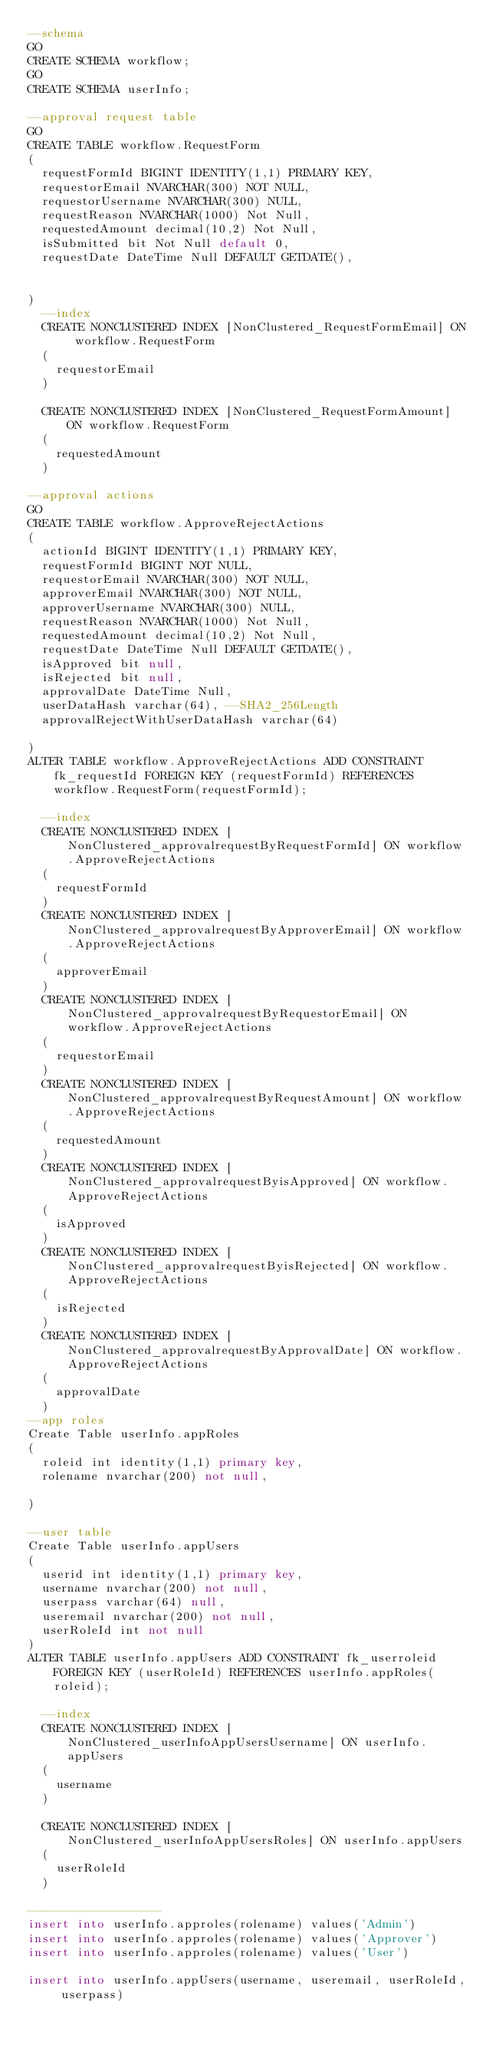<code> <loc_0><loc_0><loc_500><loc_500><_SQL_>--schema
GO 
CREATE SCHEMA workflow;
GO 
CREATE SCHEMA userInfo;

--approval request table
GO
CREATE TABLE workflow.RequestForm
(
	requestFormId BIGINT IDENTITY(1,1) PRIMARY KEY,
	requestorEmail NVARCHAR(300) NOT NULL,
	requestorUsername NVARCHAR(300) NULL,
	requestReason NVARCHAR(1000) Not Null,
	requestedAmount decimal(10,2) Not Null,
	isSubmitted bit Not Null default 0,
	requestDate DateTime Null DEFAULT GETDATE(),
	
	
)
	--index
	CREATE NONCLUSTERED INDEX [NonClustered_RequestFormEmail] ON workflow.RequestForm
	(
		requestorEmail
	)

	CREATE NONCLUSTERED INDEX [NonClustered_RequestFormAmount] ON workflow.RequestForm
	(
		requestedAmount
	)

--approval actions
GO
CREATE TABLE workflow.ApproveRejectActions
(
	actionId BIGINT IDENTITY(1,1) PRIMARY KEY,
	requestFormId BIGINT NOT NULL,
	requestorEmail NVARCHAR(300) NOT NULL,
	approverEmail NVARCHAR(300) NOT NULL,
	approverUsername NVARCHAR(300) NULL,
	requestReason NVARCHAR(1000) Not Null,
	requestedAmount decimal(10,2) Not Null,
	requestDate DateTime Null DEFAULT GETDATE(),
	isApproved bit null,
	isRejected bit null,
	approvalDate DateTime Null,
	userDataHash varchar(64), --SHA2_256Length
	approvalRejectWithUserDataHash varchar(64)
	
)
ALTER TABLE workflow.ApproveRejectActions ADD CONSTRAINT fk_requestId FOREIGN KEY (requestFormId) REFERENCES workflow.RequestForm(requestFormId);

	--index
	CREATE NONCLUSTERED INDEX [NonClustered_approvalrequestByRequestFormId] ON workflow.ApproveRejectActions
	(
		requestFormId
	)
	CREATE NONCLUSTERED INDEX [NonClustered_approvalrequestByApproverEmail] ON workflow.ApproveRejectActions
	(
		approverEmail
	)
	CREATE NONCLUSTERED INDEX [NonClustered_approvalrequestByRequestorEmail] ON workflow.ApproveRejectActions
	(
		requestorEmail
	)
	CREATE NONCLUSTERED INDEX [NonClustered_approvalrequestByRequestAmount] ON workflow.ApproveRejectActions
	(
		requestedAmount
	)
	CREATE NONCLUSTERED INDEX [NonClustered_approvalrequestByisApproved] ON workflow.ApproveRejectActions
	(
		isApproved
	)
	CREATE NONCLUSTERED INDEX [NonClustered_approvalrequestByisRejected] ON workflow.ApproveRejectActions
	(
		isRejected
	)
	CREATE NONCLUSTERED INDEX [NonClustered_approvalrequestByApprovalDate] ON workflow.ApproveRejectActions
	(
		approvalDate
	)
--app roles
Create Table userInfo.appRoles
(
	roleid int identity(1,1) primary key,
	rolename nvarchar(200) not null,

)

--user table
Create Table userInfo.appUsers
(
	userid int identity(1,1) primary key,
	username nvarchar(200) not null,
	userpass varchar(64) null,
	useremail nvarchar(200) not null,
	userRoleId int not null
)
ALTER TABLE userInfo.appUsers ADD CONSTRAINT fk_userroleid FOREIGN KEY (userRoleId) REFERENCES userInfo.appRoles(roleid);

	--index
	CREATE NONCLUSTERED INDEX [NonClustered_userInfoAppUsersUsername] ON userInfo.appUsers
	(
		username
	)

	CREATE NONCLUSTERED INDEX [NonClustered_userInfoAppUsersRoles] ON userInfo.appUsers
	(
		userRoleId
	)

-------------------
insert into userInfo.approles(rolename) values('Admin')
insert into userInfo.approles(rolename) values('Approver')
insert into userInfo.approles(rolename) values('User')

insert into userInfo.appUsers(username, useremail, userRoleId, userpass) </code> 